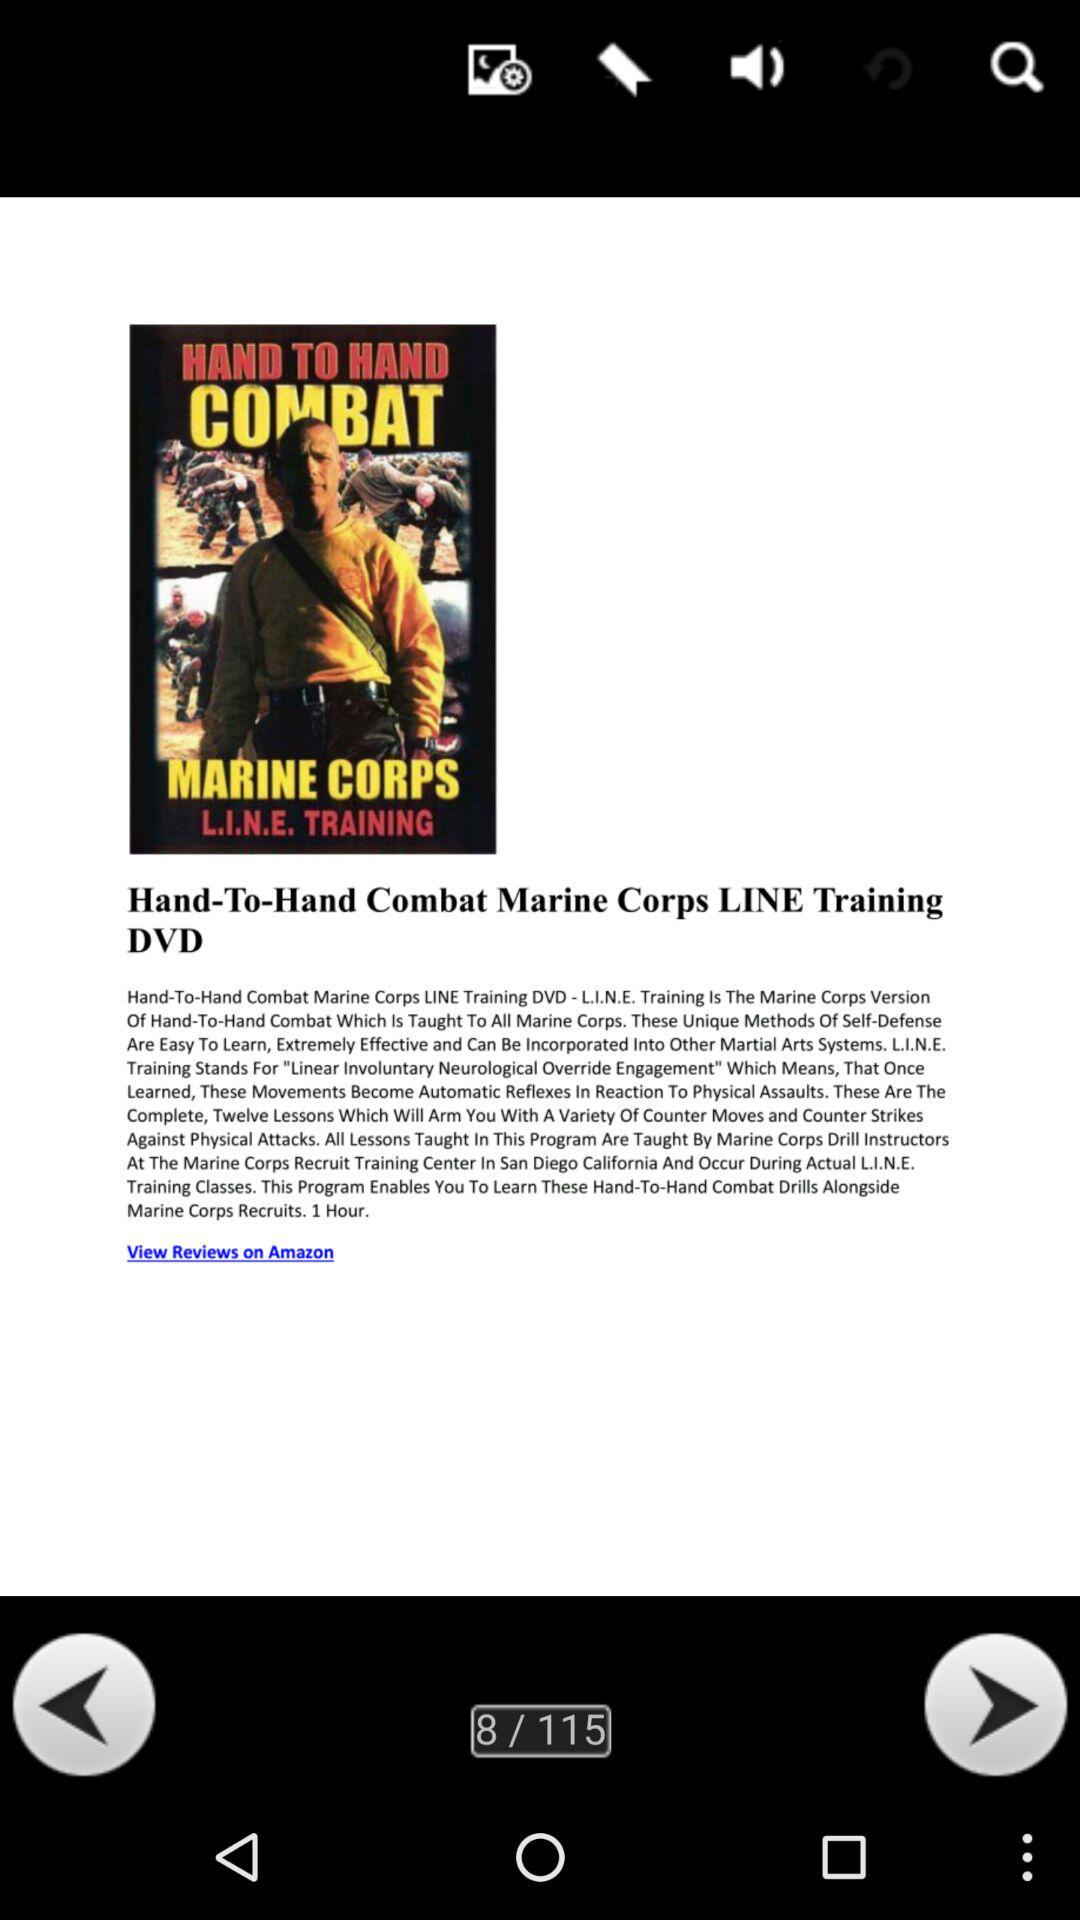What is the current slide number? The current slide number is 8. 